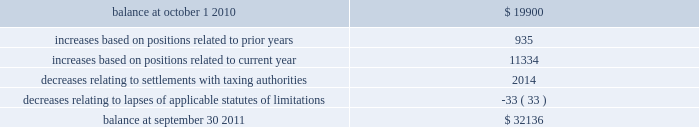Notes to consolidated financial statements 2014 ( continued ) a reconciliation of the beginning and ending amount of gross unrecognized tax benefits is as follows ( in thousands ) : .
The company 2019s major tax jurisdictions as of september 30 , 2011 are the united states , california , iowa , singapore and canada .
For the united states , the company has open tax years dating back to fiscal year 1998 due to the carry forward of tax attributes .
For california and iowa , the company has open tax years dating back to fiscal year 2002 due to the carry forward of tax attributes .
For singapore , the company has open tax years dating back to fiscal year 2011 .
For canada , the company has open tax years dating back to fiscal year 2004 .
During the year ended september 30 , 2011 , the company did not recognize any significant amount of previously unrecognized tax benefits related to the expiration of the statute of limitations .
The company 2019s policy is to recognize accrued interest and penalties , if incurred , on any unrecognized tax benefits as a component of income tax expense .
The company recognized $ 0.5 million of accrued interest or penalties related to unrecognized tax benefits during fiscal year 2011 .
11 .
Stockholders 2019 equity common stock at september 30 , 2011 , the company is authorized to issue 525000000 shares of common stock , par value $ 0.25 per share of which 195407396 shares are issued and 186386197 shares outstanding .
Holders of the company 2019s common stock are entitled to such dividends as may be declared by the company 2019s board of directors out of funds legally available for such purpose .
Dividends may not be paid on common stock unless all accrued dividends on preferred stock , if any , have been paid or declared and set aside .
In the event of the company 2019s liquidation , dissolution or winding up , the holders of common stock will be entitled to share pro rata in the assets remaining after payment to creditors and after payment of the liquidation preference plus any unpaid dividends to holders of any outstanding preferred stock .
Each holder of the company 2019s common stock is entitled to one vote for each such share outstanding in the holder 2019s name .
No holder of common stock is entitled to cumulate votes in voting for directors .
The company 2019s second amended and restated certificate of incorporation provides that , unless otherwise determined by the company 2019s board of directors , no holder of common stock has any preemptive right to purchase or subscribe for any stock of any class which the company may issue or sell .
On august 3 , 2010 , the board of directors approved a stock repurchase program , pursuant to which the company is authorized to repurchase up to $ 200.0 million of the company 2019s common stock from time to time on the open market or in privately negotiated transactions as permitted by securities laws and other legal requirements .
During the fiscal year ended september 30 , 2011 , the company paid approximately $ 70.0 million ( including commissions ) in connection with the repurchase of 2768045 shares of its common stock ( paying an average price of $ 25.30 per share ) .
As of september 30 , 2011 , $ 130.0 million remained available under the existing share repurchase program .
Page 110 skyworks / annual report 2011 .
In 2011 what was the percentage change in the gross unrecognized tax benefits? 
Computations: ((32136 - 19900) / 19900)
Answer: 0.61487. Notes to consolidated financial statements 2014 ( continued ) a reconciliation of the beginning and ending amount of gross unrecognized tax benefits is as follows ( in thousands ) : .
The company 2019s major tax jurisdictions as of september 30 , 2011 are the united states , california , iowa , singapore and canada .
For the united states , the company has open tax years dating back to fiscal year 1998 due to the carry forward of tax attributes .
For california and iowa , the company has open tax years dating back to fiscal year 2002 due to the carry forward of tax attributes .
For singapore , the company has open tax years dating back to fiscal year 2011 .
For canada , the company has open tax years dating back to fiscal year 2004 .
During the year ended september 30 , 2011 , the company did not recognize any significant amount of previously unrecognized tax benefits related to the expiration of the statute of limitations .
The company 2019s policy is to recognize accrued interest and penalties , if incurred , on any unrecognized tax benefits as a component of income tax expense .
The company recognized $ 0.5 million of accrued interest or penalties related to unrecognized tax benefits during fiscal year 2011 .
11 .
Stockholders 2019 equity common stock at september 30 , 2011 , the company is authorized to issue 525000000 shares of common stock , par value $ 0.25 per share of which 195407396 shares are issued and 186386197 shares outstanding .
Holders of the company 2019s common stock are entitled to such dividends as may be declared by the company 2019s board of directors out of funds legally available for such purpose .
Dividends may not be paid on common stock unless all accrued dividends on preferred stock , if any , have been paid or declared and set aside .
In the event of the company 2019s liquidation , dissolution or winding up , the holders of common stock will be entitled to share pro rata in the assets remaining after payment to creditors and after payment of the liquidation preference plus any unpaid dividends to holders of any outstanding preferred stock .
Each holder of the company 2019s common stock is entitled to one vote for each such share outstanding in the holder 2019s name .
No holder of common stock is entitled to cumulate votes in voting for directors .
The company 2019s second amended and restated certificate of incorporation provides that , unless otherwise determined by the company 2019s board of directors , no holder of common stock has any preemptive right to purchase or subscribe for any stock of any class which the company may issue or sell .
On august 3 , 2010 , the board of directors approved a stock repurchase program , pursuant to which the company is authorized to repurchase up to $ 200.0 million of the company 2019s common stock from time to time on the open market or in privately negotiated transactions as permitted by securities laws and other legal requirements .
During the fiscal year ended september 30 , 2011 , the company paid approximately $ 70.0 million ( including commissions ) in connection with the repurchase of 2768045 shares of its common stock ( paying an average price of $ 25.30 per share ) .
As of september 30 , 2011 , $ 130.0 million remained available under the existing share repurchase program .
Page 110 skyworks / annual report 2011 .
What is the number of shares repurchased from the company? 
Computations: (195407396 - 186386197)
Answer: 9021199.0. 